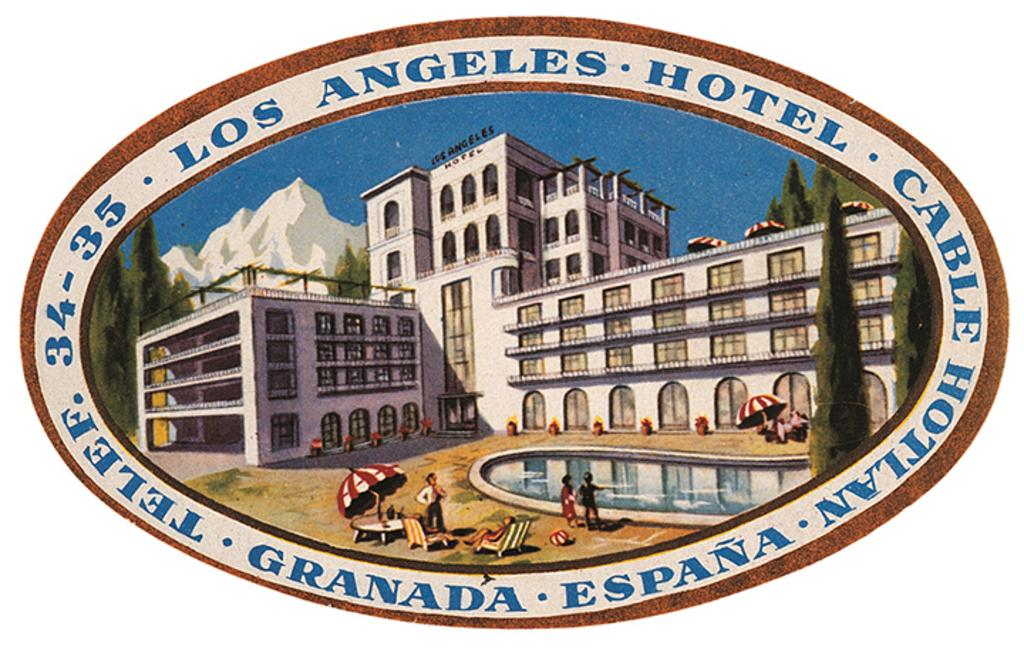What type of images are on the poster in the image? The poster contains cartoon images of buildings, trees, mountains, snow, sky, swimming pools, people, umbrellas, tables, and chairs. What is the theme of the poster? The poster features a cartoon scene with various elements, including buildings, trees, mountains, snow, sky, swimming pools, people, umbrellas, tables, and chairs. What type of beef is being cooked on the grill in the image? There is no grill or beef present in the image; it features a poster with cartoon images. How many attempts does the robin make to fly in the image? There is no robin present in the image; it features a poster with cartoon images of various elements. 